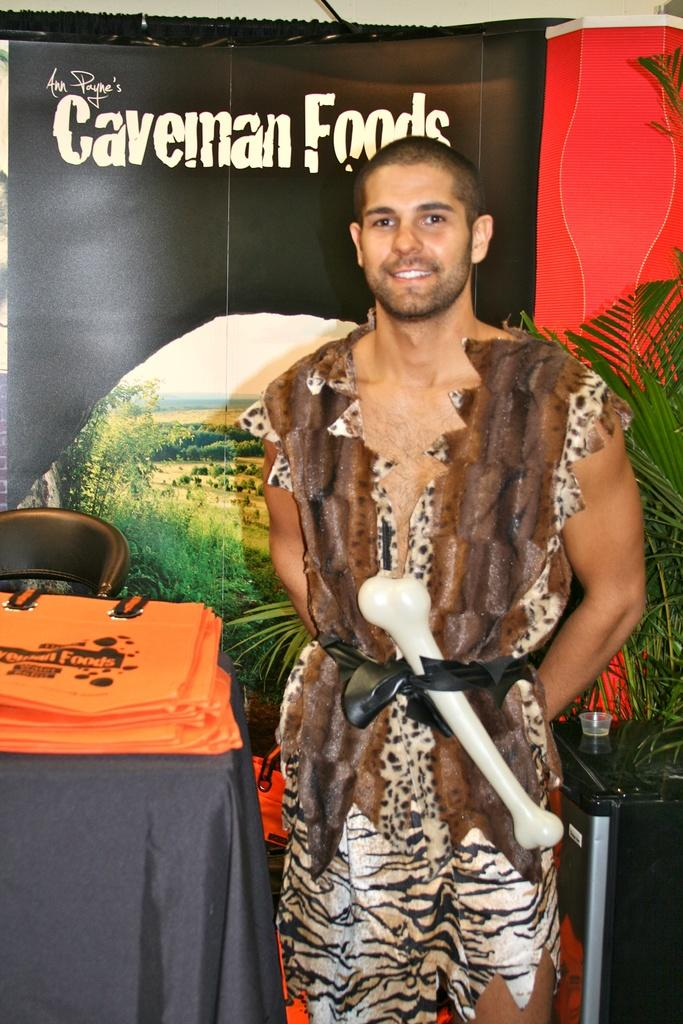Who is present in the image? There is a man in the image. What is the man's facial expression? The man is smiling. What piece of furniture is in the image? There is a table in the image. What is on the table? There is a cloth and bags on the table. What type of seating is in the image? There is a chair in the image. What type of plant is in the image? There is a plant in the image. What is in the background of the image? There is a banner in the background of the image. Can you see the receipt for the bags on the table in the image? There is no receipt visible in the image. What type of pest is crawling on the plant in the image? There are no pests visible on the plant in the image. 